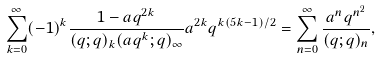<formula> <loc_0><loc_0><loc_500><loc_500>\sum ^ { \infty } _ { k = 0 } ( - 1 ) ^ { k } \frac { 1 - a q ^ { 2 k } } { ( q ; q ) _ { k } ( a q ^ { k } ; q ) _ { \infty } } a ^ { 2 k } q ^ { k ( 5 k - 1 ) / 2 } = \sum ^ { \infty } _ { n = 0 } \frac { a ^ { n } q ^ { n ^ { 2 } } } { ( q ; q ) _ { n } } ,</formula> 